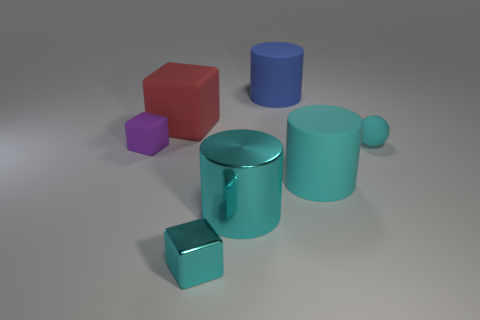How many cylinders are red rubber objects or cyan things?
Offer a very short reply. 2. How many matte cylinders are right of the small matte object behind the tiny purple rubber cube?
Offer a terse response. 0. Does the small cyan shiny thing have the same shape as the red thing?
Ensure brevity in your answer.  Yes. There is a red object that is the same shape as the small cyan metal object; what size is it?
Provide a short and direct response. Large. There is a cyan metal thing on the right side of the tiny cyan metallic block left of the blue cylinder; what is its shape?
Your answer should be very brief. Cylinder. The purple cube has what size?
Offer a very short reply. Small. What is the shape of the big blue matte object?
Ensure brevity in your answer.  Cylinder. There is a large blue thing; does it have the same shape as the cyan matte object in front of the purple matte thing?
Offer a terse response. Yes. Is the shape of the big cyan object that is in front of the big cyan matte object the same as  the blue object?
Provide a short and direct response. Yes. What number of cyan objects are right of the small cyan block and to the left of the small cyan ball?
Provide a succinct answer. 2. 